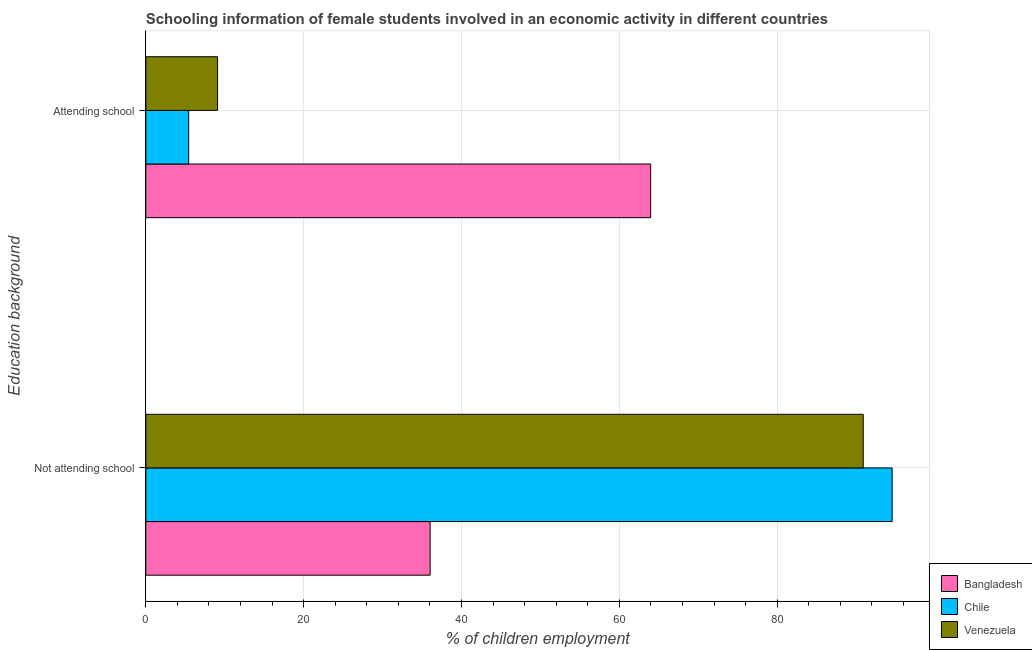How many different coloured bars are there?
Make the answer very short. 3. Are the number of bars on each tick of the Y-axis equal?
Offer a terse response. Yes. What is the label of the 2nd group of bars from the top?
Make the answer very short. Not attending school. What is the percentage of employed females who are attending school in Venezuela?
Your answer should be compact. 9.09. Across all countries, what is the maximum percentage of employed females who are not attending school?
Offer a very short reply. 94.57. Across all countries, what is the minimum percentage of employed females who are not attending school?
Keep it short and to the point. 36.02. What is the total percentage of employed females who are not attending school in the graph?
Make the answer very short. 221.51. What is the difference between the percentage of employed females who are attending school in Chile and that in Venezuela?
Your answer should be compact. -3.67. What is the difference between the percentage of employed females who are attending school in Chile and the percentage of employed females who are not attending school in Bangladesh?
Give a very brief answer. -30.6. What is the average percentage of employed females who are attending school per country?
Offer a very short reply. 26.16. What is the difference between the percentage of employed females who are not attending school and percentage of employed females who are attending school in Bangladesh?
Your response must be concise. -27.95. What is the ratio of the percentage of employed females who are not attending school in Chile to that in Venezuela?
Your answer should be compact. 1.04. What does the 1st bar from the top in Attending school represents?
Provide a short and direct response. Venezuela. What does the 1st bar from the bottom in Not attending school represents?
Provide a succinct answer. Bangladesh. What is the difference between two consecutive major ticks on the X-axis?
Your answer should be compact. 20. Does the graph contain any zero values?
Your answer should be very brief. No. Where does the legend appear in the graph?
Provide a short and direct response. Bottom right. What is the title of the graph?
Make the answer very short. Schooling information of female students involved in an economic activity in different countries. What is the label or title of the X-axis?
Provide a succinct answer. % of children employment. What is the label or title of the Y-axis?
Your answer should be compact. Education background. What is the % of children employment of Bangladesh in Not attending school?
Provide a succinct answer. 36.02. What is the % of children employment of Chile in Not attending school?
Offer a terse response. 94.57. What is the % of children employment in Venezuela in Not attending school?
Make the answer very short. 90.91. What is the % of children employment in Bangladesh in Attending school?
Ensure brevity in your answer.  63.98. What is the % of children employment of Chile in Attending school?
Your response must be concise. 5.43. What is the % of children employment of Venezuela in Attending school?
Provide a short and direct response. 9.09. Across all Education background, what is the maximum % of children employment in Bangladesh?
Make the answer very short. 63.98. Across all Education background, what is the maximum % of children employment in Chile?
Ensure brevity in your answer.  94.57. Across all Education background, what is the maximum % of children employment of Venezuela?
Make the answer very short. 90.91. Across all Education background, what is the minimum % of children employment of Bangladesh?
Provide a short and direct response. 36.02. Across all Education background, what is the minimum % of children employment of Chile?
Provide a short and direct response. 5.43. Across all Education background, what is the minimum % of children employment in Venezuela?
Keep it short and to the point. 9.09. What is the total % of children employment of Bangladesh in the graph?
Give a very brief answer. 100. What is the total % of children employment of Chile in the graph?
Provide a succinct answer. 100. What is the difference between the % of children employment of Bangladesh in Not attending school and that in Attending school?
Your answer should be compact. -27.95. What is the difference between the % of children employment of Chile in Not attending school and that in Attending school?
Give a very brief answer. 89.15. What is the difference between the % of children employment in Venezuela in Not attending school and that in Attending school?
Make the answer very short. 81.82. What is the difference between the % of children employment in Bangladesh in Not attending school and the % of children employment in Chile in Attending school?
Make the answer very short. 30.6. What is the difference between the % of children employment of Bangladesh in Not attending school and the % of children employment of Venezuela in Attending school?
Your answer should be very brief. 26.93. What is the difference between the % of children employment in Chile in Not attending school and the % of children employment in Venezuela in Attending school?
Ensure brevity in your answer.  85.48. What is the difference between the % of children employment of Bangladesh and % of children employment of Chile in Not attending school?
Your response must be concise. -58.55. What is the difference between the % of children employment of Bangladesh and % of children employment of Venezuela in Not attending school?
Provide a short and direct response. -54.88. What is the difference between the % of children employment in Chile and % of children employment in Venezuela in Not attending school?
Provide a short and direct response. 3.67. What is the difference between the % of children employment of Bangladesh and % of children employment of Chile in Attending school?
Provide a short and direct response. 58.55. What is the difference between the % of children employment of Bangladesh and % of children employment of Venezuela in Attending school?
Provide a succinct answer. 54.88. What is the difference between the % of children employment of Chile and % of children employment of Venezuela in Attending school?
Offer a terse response. -3.67. What is the ratio of the % of children employment of Bangladesh in Not attending school to that in Attending school?
Offer a very short reply. 0.56. What is the ratio of the % of children employment of Chile in Not attending school to that in Attending school?
Offer a terse response. 17.43. What is the ratio of the % of children employment in Venezuela in Not attending school to that in Attending school?
Make the answer very short. 10. What is the difference between the highest and the second highest % of children employment in Bangladesh?
Give a very brief answer. 27.95. What is the difference between the highest and the second highest % of children employment in Chile?
Provide a succinct answer. 89.15. What is the difference between the highest and the second highest % of children employment in Venezuela?
Ensure brevity in your answer.  81.82. What is the difference between the highest and the lowest % of children employment of Bangladesh?
Give a very brief answer. 27.95. What is the difference between the highest and the lowest % of children employment of Chile?
Your answer should be very brief. 89.15. What is the difference between the highest and the lowest % of children employment in Venezuela?
Your answer should be very brief. 81.82. 